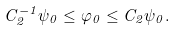<formula> <loc_0><loc_0><loc_500><loc_500>C ^ { - 1 } _ { 2 } \psi _ { 0 } \leq \varphi _ { 0 } \leq C _ { 2 } \psi _ { 0 } .</formula> 